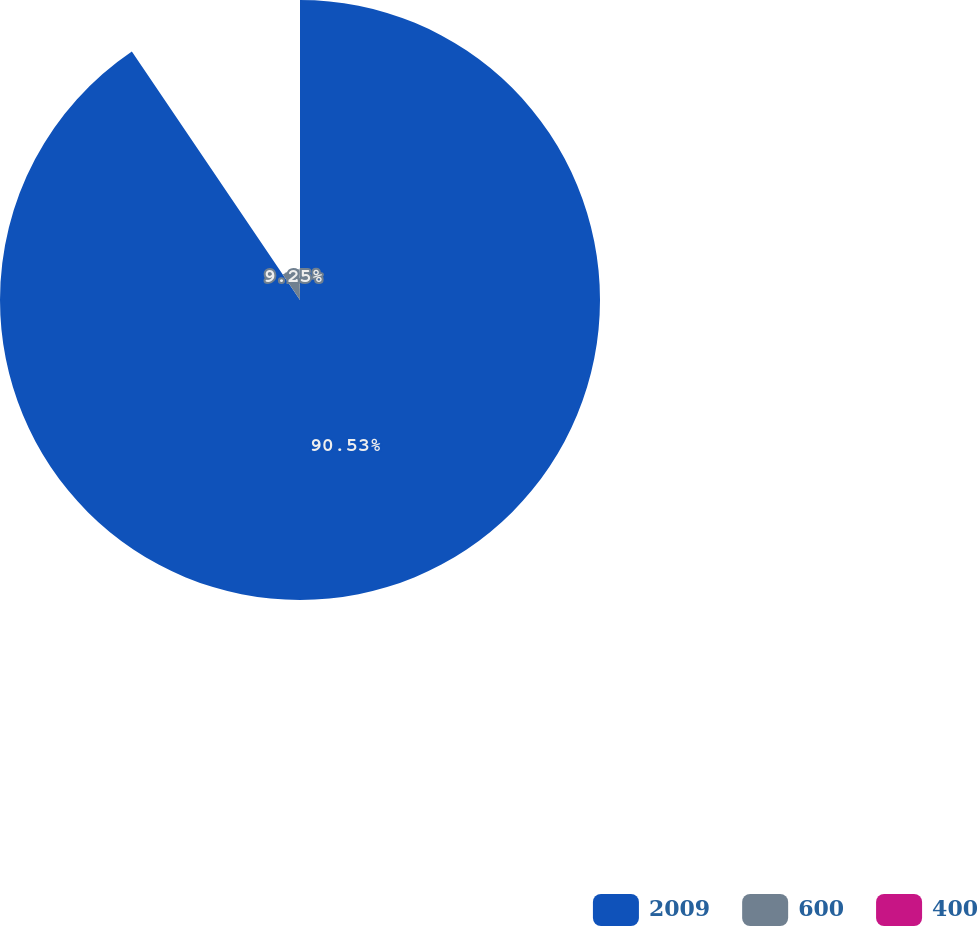Convert chart to OTSL. <chart><loc_0><loc_0><loc_500><loc_500><pie_chart><fcel>2009<fcel>600<fcel>400<nl><fcel>90.53%<fcel>9.25%<fcel>0.22%<nl></chart> 